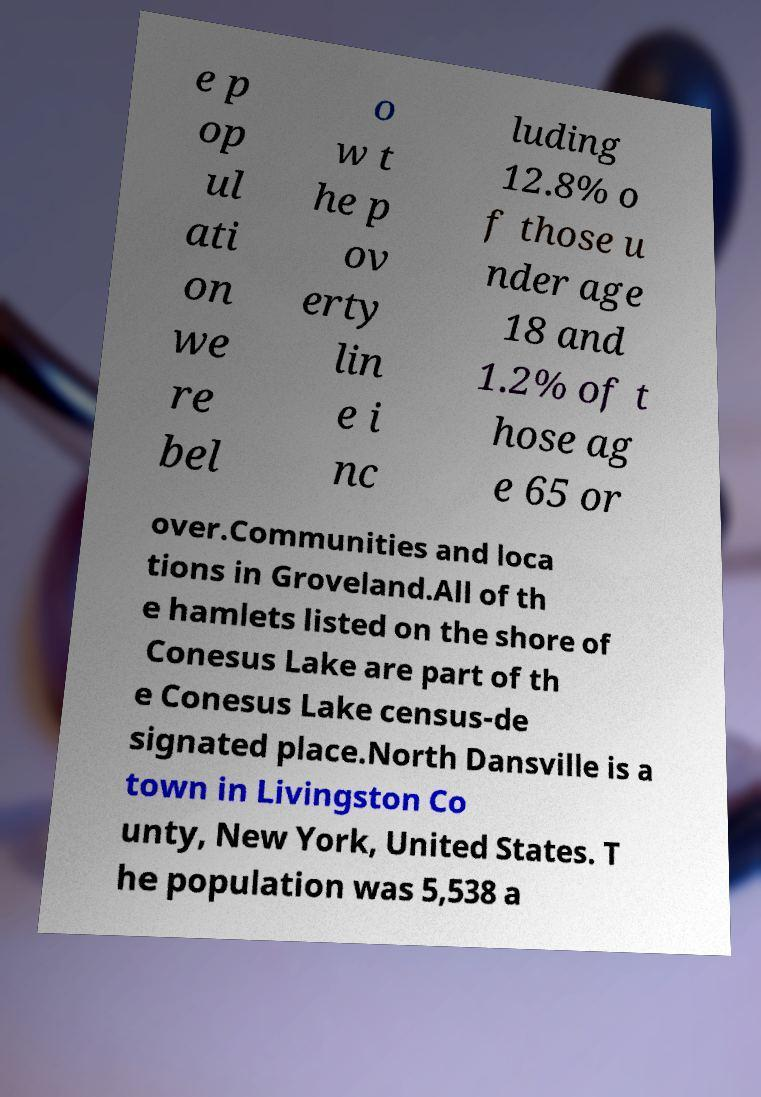Could you extract and type out the text from this image? e p op ul ati on we re bel o w t he p ov erty lin e i nc luding 12.8% o f those u nder age 18 and 1.2% of t hose ag e 65 or over.Communities and loca tions in Groveland.All of th e hamlets listed on the shore of Conesus Lake are part of th e Conesus Lake census-de signated place.North Dansville is a town in Livingston Co unty, New York, United States. T he population was 5,538 a 